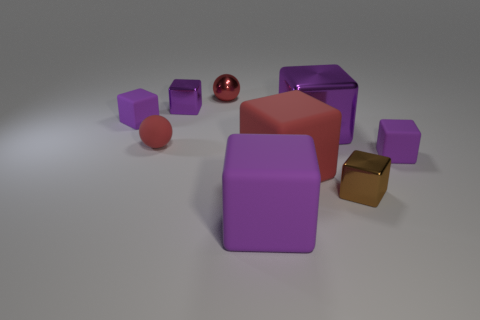Is there a big purple cube made of the same material as the small brown object?
Your answer should be very brief. Yes. Do the metal ball and the purple metal object in front of the small purple shiny object have the same size?
Make the answer very short. No. Are there any small rubber things of the same color as the metallic sphere?
Offer a very short reply. Yes. Does the red block have the same material as the tiny brown thing?
Offer a very short reply. No. There is a matte sphere; what number of red matte cubes are behind it?
Provide a succinct answer. 0. What is the tiny object that is on the right side of the tiny metal sphere and behind the small brown cube made of?
Offer a very short reply. Rubber. What number of brown metal cubes have the same size as the red matte sphere?
Your answer should be very brief. 1. What is the color of the small rubber thing on the right side of the red sphere to the right of the small red rubber thing?
Keep it short and to the point. Purple. Are any big cyan objects visible?
Your response must be concise. No. Does the large purple shiny thing have the same shape as the large red matte thing?
Your response must be concise. Yes. 